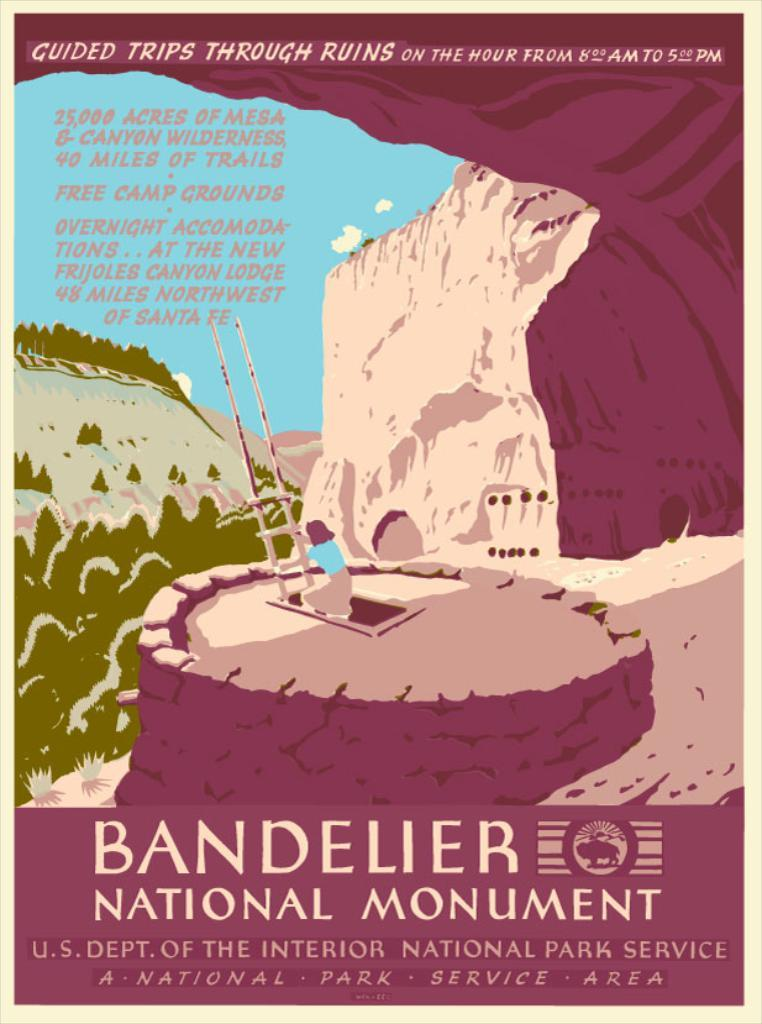What is featured on the poster in the image? The poster contains an image of a person, a ladder, and a wall. What else can be seen on the poster besides the images? There is text at the top and bottom of the poster. What is visible in the background of the image? Trees are visible in the background of the image. Who is the creator of the grape that is hidden behind the wall in the image? There is no grape present in the image, and therefore no creator can be identified. 